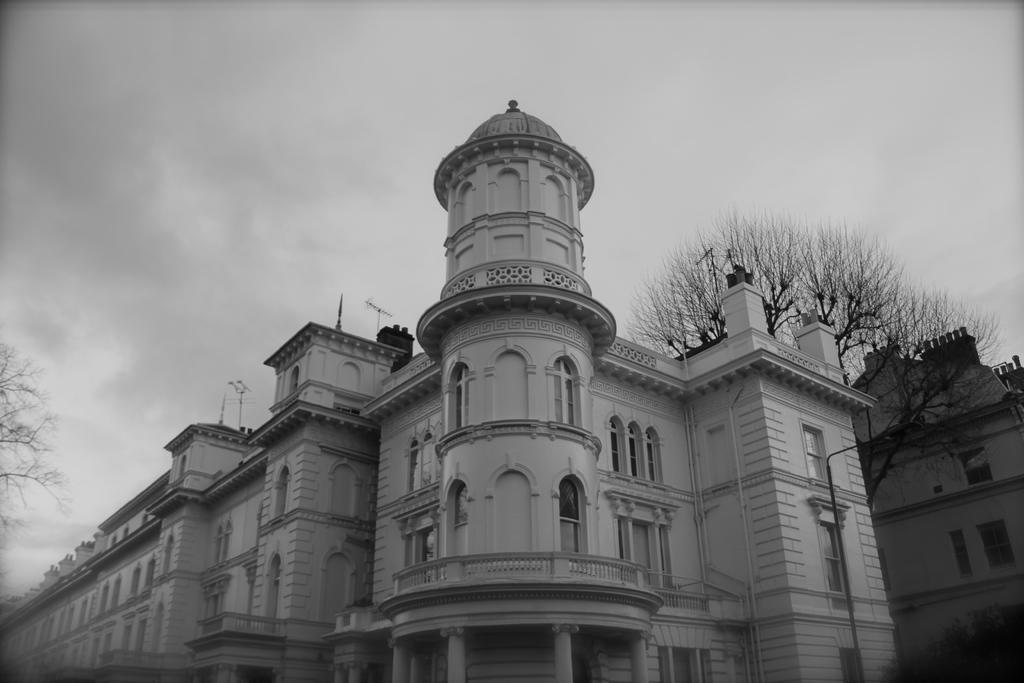What type of structures can be seen in the image? There are buildings in the image. What other natural elements are present in the image? There are trees and clouds in the image. What is the color scheme of the image? The image is in black and white. What type of zinc is visible in the image? There is no zinc present in the image. Can you see any veins in the image? The image does not depict any living organisms, so there are no veins visible. 